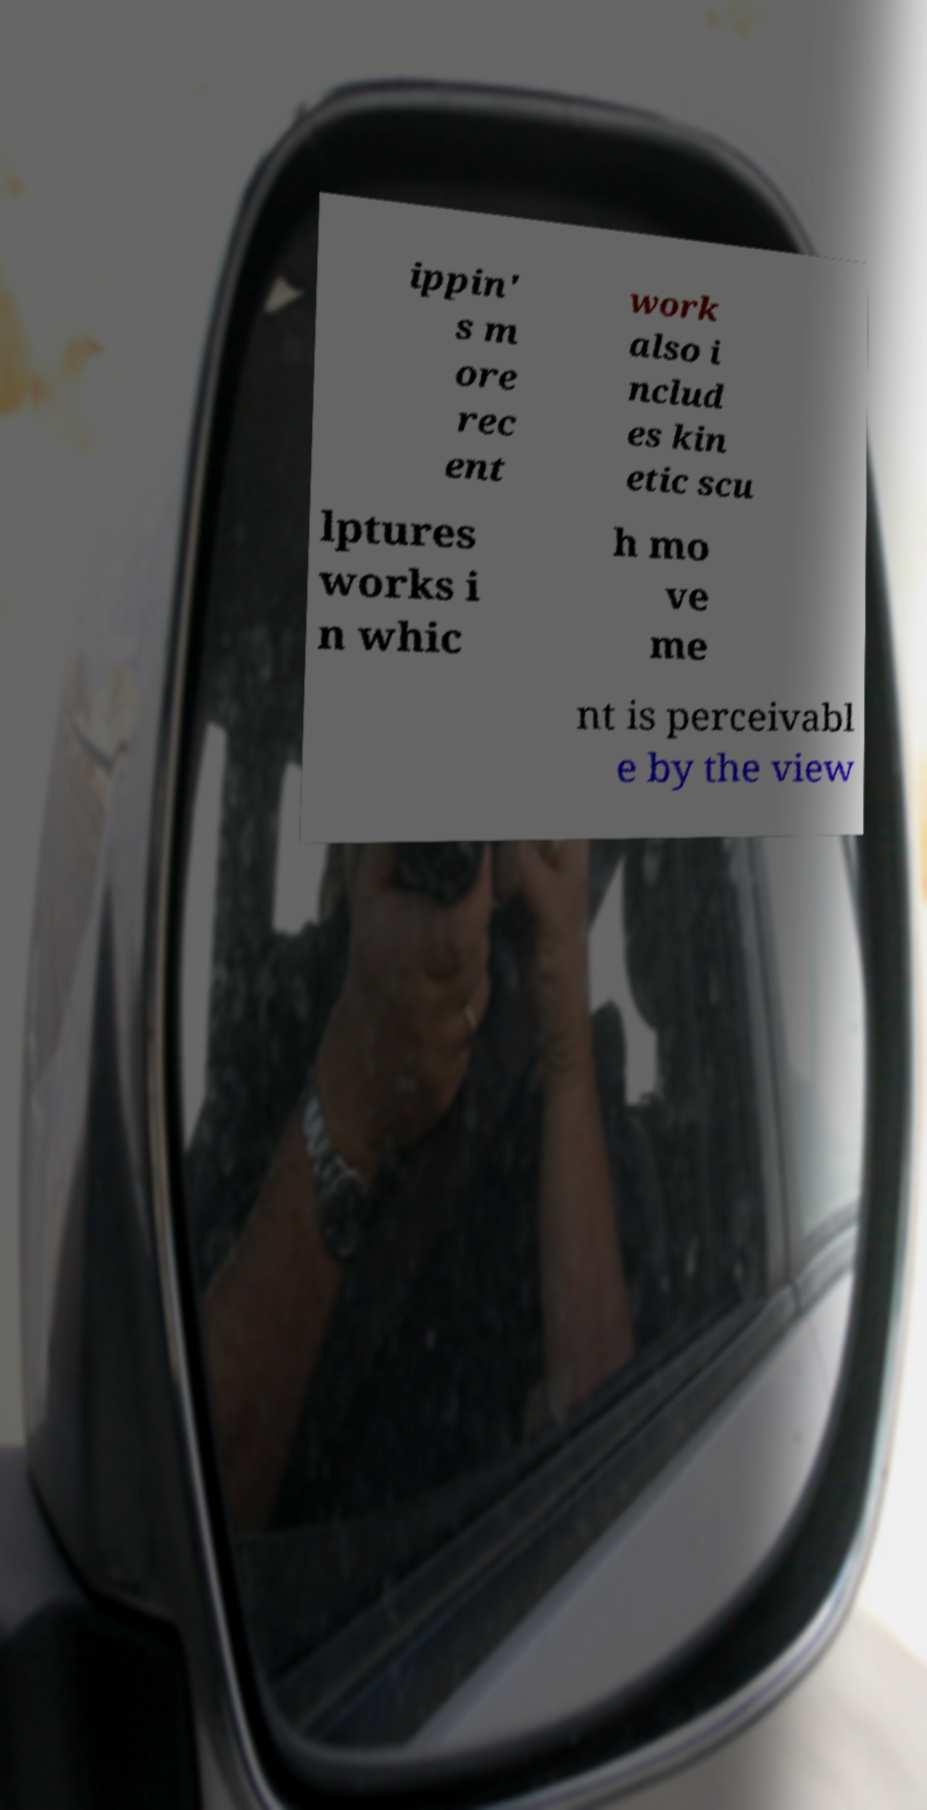For documentation purposes, I need the text within this image transcribed. Could you provide that? ippin' s m ore rec ent work also i nclud es kin etic scu lptures works i n whic h mo ve me nt is perceivabl e by the view 